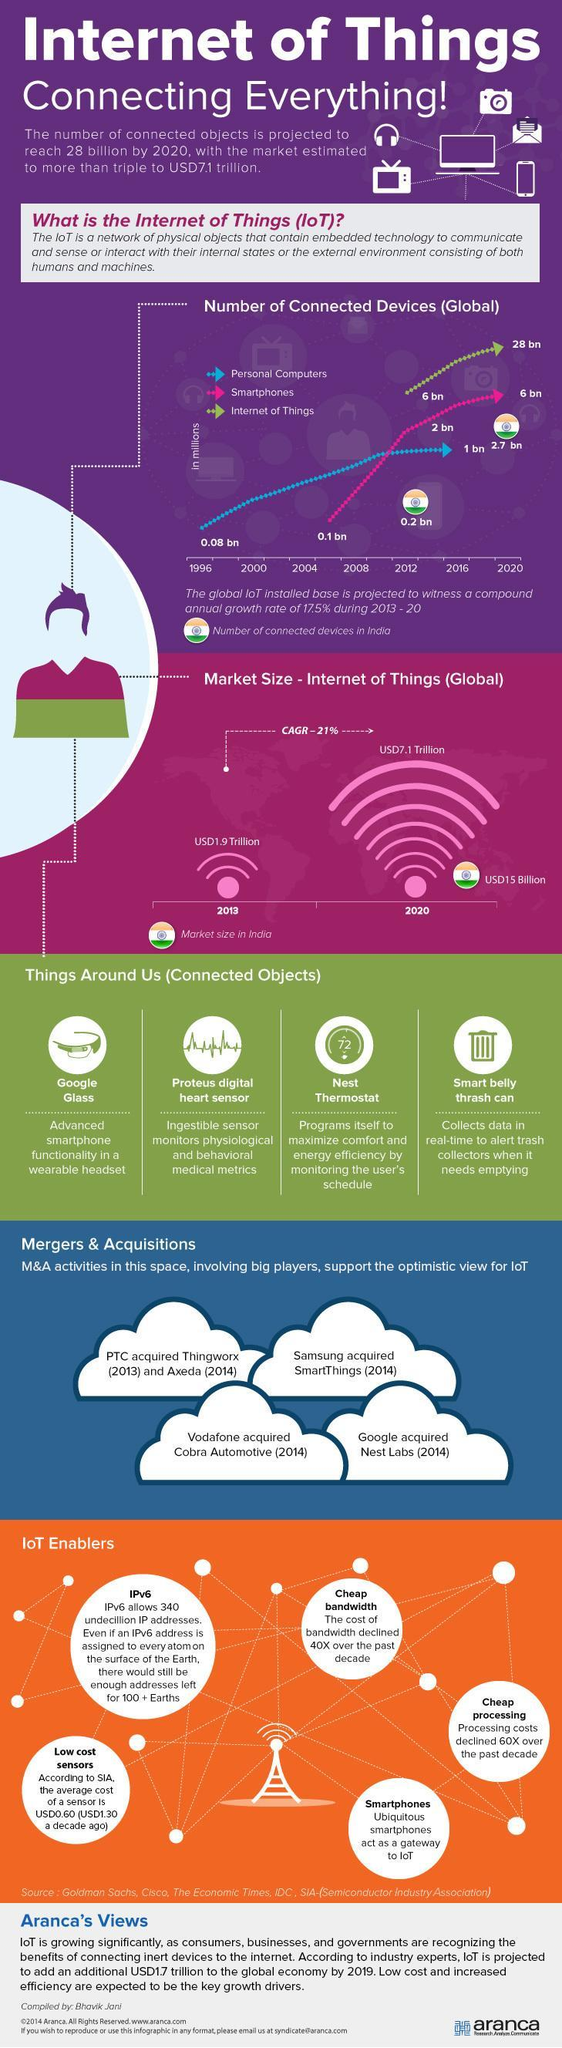What is the number of IoT connected devices globally in 2020?
Answer the question with a short phrase. 28 bn How many smartphones will be connected to the IoT by 2020? 6 bn What is the market value of IoT globally in 2020? USD7.1 Trillion What is the market value of IoT in India in 2020? USD15 Billion What is the market value of IoT globally in 2013? USD1.9 Trillion What is the number of IoT connections in India in 2020? 2.7 bn What is the number of IoT connections in India in 2012? 0.2 bn 